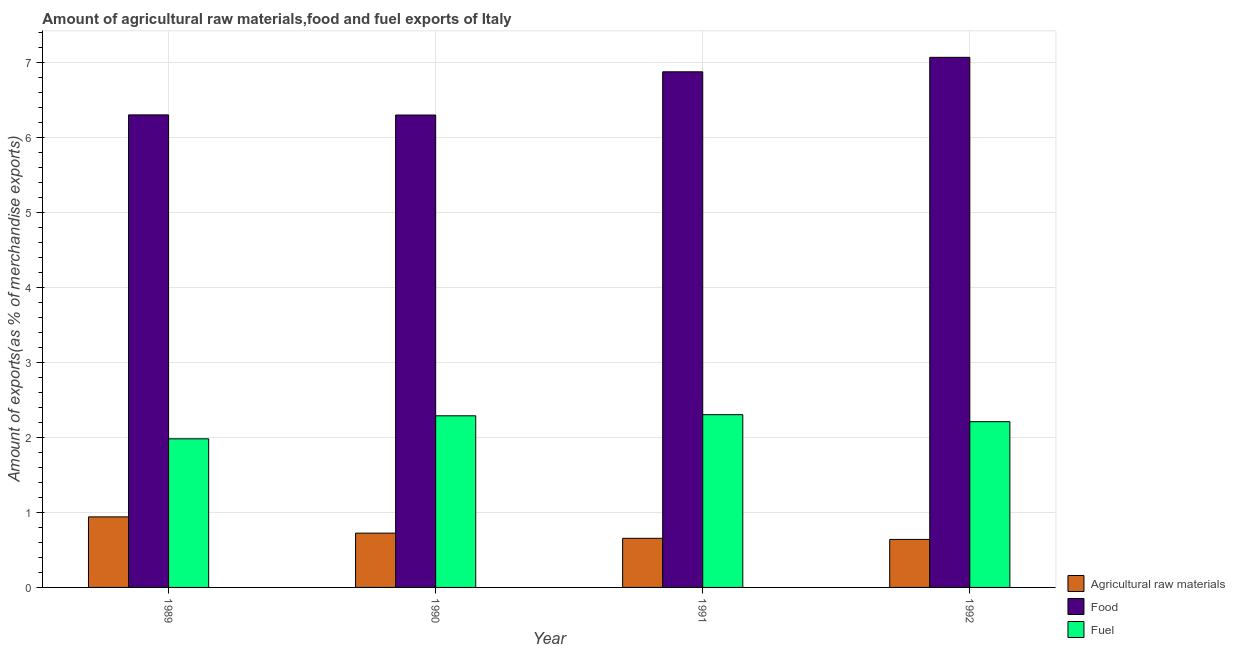How many groups of bars are there?
Offer a very short reply. 4. Are the number of bars per tick equal to the number of legend labels?
Make the answer very short. Yes. Are the number of bars on each tick of the X-axis equal?
Offer a very short reply. Yes. How many bars are there on the 4th tick from the left?
Your answer should be compact. 3. How many bars are there on the 4th tick from the right?
Your response must be concise. 3. In how many cases, is the number of bars for a given year not equal to the number of legend labels?
Keep it short and to the point. 0. What is the percentage of fuel exports in 1990?
Ensure brevity in your answer.  2.29. Across all years, what is the maximum percentage of raw materials exports?
Give a very brief answer. 0.94. Across all years, what is the minimum percentage of raw materials exports?
Give a very brief answer. 0.64. What is the total percentage of raw materials exports in the graph?
Your response must be concise. 2.96. What is the difference between the percentage of raw materials exports in 1991 and that in 1992?
Ensure brevity in your answer.  0.01. What is the difference between the percentage of fuel exports in 1992 and the percentage of food exports in 1990?
Provide a short and direct response. -0.08. What is the average percentage of fuel exports per year?
Your response must be concise. 2.2. In the year 1992, what is the difference between the percentage of food exports and percentage of raw materials exports?
Offer a terse response. 0. What is the ratio of the percentage of food exports in 1991 to that in 1992?
Give a very brief answer. 0.97. Is the difference between the percentage of fuel exports in 1989 and 1992 greater than the difference between the percentage of raw materials exports in 1989 and 1992?
Offer a very short reply. No. What is the difference between the highest and the second highest percentage of raw materials exports?
Give a very brief answer. 0.22. What is the difference between the highest and the lowest percentage of food exports?
Offer a terse response. 0.77. Is the sum of the percentage of raw materials exports in 1991 and 1992 greater than the maximum percentage of food exports across all years?
Your answer should be compact. Yes. What does the 1st bar from the left in 1990 represents?
Provide a succinct answer. Agricultural raw materials. What does the 2nd bar from the right in 1991 represents?
Your answer should be very brief. Food. Is it the case that in every year, the sum of the percentage of raw materials exports and percentage of food exports is greater than the percentage of fuel exports?
Provide a short and direct response. Yes. Are the values on the major ticks of Y-axis written in scientific E-notation?
Your answer should be compact. No. Where does the legend appear in the graph?
Offer a terse response. Bottom right. How many legend labels are there?
Make the answer very short. 3. How are the legend labels stacked?
Offer a terse response. Vertical. What is the title of the graph?
Provide a short and direct response. Amount of agricultural raw materials,food and fuel exports of Italy. Does "Hydroelectric sources" appear as one of the legend labels in the graph?
Provide a succinct answer. No. What is the label or title of the Y-axis?
Provide a short and direct response. Amount of exports(as % of merchandise exports). What is the Amount of exports(as % of merchandise exports) of Agricultural raw materials in 1989?
Offer a terse response. 0.94. What is the Amount of exports(as % of merchandise exports) in Food in 1989?
Ensure brevity in your answer.  6.3. What is the Amount of exports(as % of merchandise exports) in Fuel in 1989?
Keep it short and to the point. 1.98. What is the Amount of exports(as % of merchandise exports) in Agricultural raw materials in 1990?
Give a very brief answer. 0.72. What is the Amount of exports(as % of merchandise exports) of Food in 1990?
Ensure brevity in your answer.  6.3. What is the Amount of exports(as % of merchandise exports) in Fuel in 1990?
Provide a succinct answer. 2.29. What is the Amount of exports(as % of merchandise exports) of Agricultural raw materials in 1991?
Provide a succinct answer. 0.66. What is the Amount of exports(as % of merchandise exports) in Food in 1991?
Your answer should be compact. 6.88. What is the Amount of exports(as % of merchandise exports) of Fuel in 1991?
Provide a succinct answer. 2.3. What is the Amount of exports(as % of merchandise exports) in Agricultural raw materials in 1992?
Provide a succinct answer. 0.64. What is the Amount of exports(as % of merchandise exports) in Food in 1992?
Ensure brevity in your answer.  7.07. What is the Amount of exports(as % of merchandise exports) of Fuel in 1992?
Ensure brevity in your answer.  2.21. Across all years, what is the maximum Amount of exports(as % of merchandise exports) in Agricultural raw materials?
Give a very brief answer. 0.94. Across all years, what is the maximum Amount of exports(as % of merchandise exports) of Food?
Make the answer very short. 7.07. Across all years, what is the maximum Amount of exports(as % of merchandise exports) in Fuel?
Provide a succinct answer. 2.3. Across all years, what is the minimum Amount of exports(as % of merchandise exports) in Agricultural raw materials?
Your answer should be very brief. 0.64. Across all years, what is the minimum Amount of exports(as % of merchandise exports) in Food?
Keep it short and to the point. 6.3. Across all years, what is the minimum Amount of exports(as % of merchandise exports) in Fuel?
Your response must be concise. 1.98. What is the total Amount of exports(as % of merchandise exports) of Agricultural raw materials in the graph?
Your response must be concise. 2.96. What is the total Amount of exports(as % of merchandise exports) in Food in the graph?
Provide a succinct answer. 26.55. What is the total Amount of exports(as % of merchandise exports) of Fuel in the graph?
Make the answer very short. 8.79. What is the difference between the Amount of exports(as % of merchandise exports) of Agricultural raw materials in 1989 and that in 1990?
Offer a terse response. 0.22. What is the difference between the Amount of exports(as % of merchandise exports) of Food in 1989 and that in 1990?
Your answer should be very brief. 0. What is the difference between the Amount of exports(as % of merchandise exports) of Fuel in 1989 and that in 1990?
Your response must be concise. -0.31. What is the difference between the Amount of exports(as % of merchandise exports) of Agricultural raw materials in 1989 and that in 1991?
Your answer should be very brief. 0.29. What is the difference between the Amount of exports(as % of merchandise exports) of Food in 1989 and that in 1991?
Provide a short and direct response. -0.57. What is the difference between the Amount of exports(as % of merchandise exports) in Fuel in 1989 and that in 1991?
Offer a very short reply. -0.32. What is the difference between the Amount of exports(as % of merchandise exports) in Agricultural raw materials in 1989 and that in 1992?
Your answer should be compact. 0.3. What is the difference between the Amount of exports(as % of merchandise exports) of Food in 1989 and that in 1992?
Keep it short and to the point. -0.77. What is the difference between the Amount of exports(as % of merchandise exports) of Fuel in 1989 and that in 1992?
Make the answer very short. -0.23. What is the difference between the Amount of exports(as % of merchandise exports) of Agricultural raw materials in 1990 and that in 1991?
Make the answer very short. 0.07. What is the difference between the Amount of exports(as % of merchandise exports) of Food in 1990 and that in 1991?
Your response must be concise. -0.58. What is the difference between the Amount of exports(as % of merchandise exports) of Fuel in 1990 and that in 1991?
Give a very brief answer. -0.01. What is the difference between the Amount of exports(as % of merchandise exports) of Agricultural raw materials in 1990 and that in 1992?
Your answer should be compact. 0.08. What is the difference between the Amount of exports(as % of merchandise exports) in Food in 1990 and that in 1992?
Ensure brevity in your answer.  -0.77. What is the difference between the Amount of exports(as % of merchandise exports) of Fuel in 1990 and that in 1992?
Your answer should be compact. 0.08. What is the difference between the Amount of exports(as % of merchandise exports) of Agricultural raw materials in 1991 and that in 1992?
Ensure brevity in your answer.  0.01. What is the difference between the Amount of exports(as % of merchandise exports) in Food in 1991 and that in 1992?
Your answer should be very brief. -0.19. What is the difference between the Amount of exports(as % of merchandise exports) in Fuel in 1991 and that in 1992?
Offer a terse response. 0.09. What is the difference between the Amount of exports(as % of merchandise exports) in Agricultural raw materials in 1989 and the Amount of exports(as % of merchandise exports) in Food in 1990?
Your answer should be very brief. -5.36. What is the difference between the Amount of exports(as % of merchandise exports) in Agricultural raw materials in 1989 and the Amount of exports(as % of merchandise exports) in Fuel in 1990?
Make the answer very short. -1.35. What is the difference between the Amount of exports(as % of merchandise exports) in Food in 1989 and the Amount of exports(as % of merchandise exports) in Fuel in 1990?
Offer a terse response. 4.01. What is the difference between the Amount of exports(as % of merchandise exports) of Agricultural raw materials in 1989 and the Amount of exports(as % of merchandise exports) of Food in 1991?
Your response must be concise. -5.94. What is the difference between the Amount of exports(as % of merchandise exports) in Agricultural raw materials in 1989 and the Amount of exports(as % of merchandise exports) in Fuel in 1991?
Provide a succinct answer. -1.36. What is the difference between the Amount of exports(as % of merchandise exports) of Food in 1989 and the Amount of exports(as % of merchandise exports) of Fuel in 1991?
Provide a succinct answer. 4. What is the difference between the Amount of exports(as % of merchandise exports) in Agricultural raw materials in 1989 and the Amount of exports(as % of merchandise exports) in Food in 1992?
Provide a short and direct response. -6.13. What is the difference between the Amount of exports(as % of merchandise exports) in Agricultural raw materials in 1989 and the Amount of exports(as % of merchandise exports) in Fuel in 1992?
Your response must be concise. -1.27. What is the difference between the Amount of exports(as % of merchandise exports) of Food in 1989 and the Amount of exports(as % of merchandise exports) of Fuel in 1992?
Offer a very short reply. 4.09. What is the difference between the Amount of exports(as % of merchandise exports) in Agricultural raw materials in 1990 and the Amount of exports(as % of merchandise exports) in Food in 1991?
Your answer should be very brief. -6.15. What is the difference between the Amount of exports(as % of merchandise exports) of Agricultural raw materials in 1990 and the Amount of exports(as % of merchandise exports) of Fuel in 1991?
Provide a succinct answer. -1.58. What is the difference between the Amount of exports(as % of merchandise exports) of Food in 1990 and the Amount of exports(as % of merchandise exports) of Fuel in 1991?
Offer a terse response. 4. What is the difference between the Amount of exports(as % of merchandise exports) of Agricultural raw materials in 1990 and the Amount of exports(as % of merchandise exports) of Food in 1992?
Offer a very short reply. -6.35. What is the difference between the Amount of exports(as % of merchandise exports) in Agricultural raw materials in 1990 and the Amount of exports(as % of merchandise exports) in Fuel in 1992?
Offer a very short reply. -1.49. What is the difference between the Amount of exports(as % of merchandise exports) of Food in 1990 and the Amount of exports(as % of merchandise exports) of Fuel in 1992?
Keep it short and to the point. 4.09. What is the difference between the Amount of exports(as % of merchandise exports) in Agricultural raw materials in 1991 and the Amount of exports(as % of merchandise exports) in Food in 1992?
Your response must be concise. -6.42. What is the difference between the Amount of exports(as % of merchandise exports) of Agricultural raw materials in 1991 and the Amount of exports(as % of merchandise exports) of Fuel in 1992?
Offer a terse response. -1.56. What is the difference between the Amount of exports(as % of merchandise exports) of Food in 1991 and the Amount of exports(as % of merchandise exports) of Fuel in 1992?
Provide a succinct answer. 4.67. What is the average Amount of exports(as % of merchandise exports) of Agricultural raw materials per year?
Give a very brief answer. 0.74. What is the average Amount of exports(as % of merchandise exports) in Food per year?
Provide a short and direct response. 6.64. What is the average Amount of exports(as % of merchandise exports) in Fuel per year?
Offer a very short reply. 2.2. In the year 1989, what is the difference between the Amount of exports(as % of merchandise exports) of Agricultural raw materials and Amount of exports(as % of merchandise exports) of Food?
Offer a terse response. -5.36. In the year 1989, what is the difference between the Amount of exports(as % of merchandise exports) of Agricultural raw materials and Amount of exports(as % of merchandise exports) of Fuel?
Provide a short and direct response. -1.04. In the year 1989, what is the difference between the Amount of exports(as % of merchandise exports) in Food and Amount of exports(as % of merchandise exports) in Fuel?
Ensure brevity in your answer.  4.32. In the year 1990, what is the difference between the Amount of exports(as % of merchandise exports) of Agricultural raw materials and Amount of exports(as % of merchandise exports) of Food?
Your answer should be compact. -5.58. In the year 1990, what is the difference between the Amount of exports(as % of merchandise exports) of Agricultural raw materials and Amount of exports(as % of merchandise exports) of Fuel?
Keep it short and to the point. -1.57. In the year 1990, what is the difference between the Amount of exports(as % of merchandise exports) of Food and Amount of exports(as % of merchandise exports) of Fuel?
Your response must be concise. 4.01. In the year 1991, what is the difference between the Amount of exports(as % of merchandise exports) in Agricultural raw materials and Amount of exports(as % of merchandise exports) in Food?
Provide a succinct answer. -6.22. In the year 1991, what is the difference between the Amount of exports(as % of merchandise exports) in Agricultural raw materials and Amount of exports(as % of merchandise exports) in Fuel?
Your answer should be very brief. -1.65. In the year 1991, what is the difference between the Amount of exports(as % of merchandise exports) in Food and Amount of exports(as % of merchandise exports) in Fuel?
Your answer should be very brief. 4.57. In the year 1992, what is the difference between the Amount of exports(as % of merchandise exports) of Agricultural raw materials and Amount of exports(as % of merchandise exports) of Food?
Ensure brevity in your answer.  -6.43. In the year 1992, what is the difference between the Amount of exports(as % of merchandise exports) in Agricultural raw materials and Amount of exports(as % of merchandise exports) in Fuel?
Your response must be concise. -1.57. In the year 1992, what is the difference between the Amount of exports(as % of merchandise exports) of Food and Amount of exports(as % of merchandise exports) of Fuel?
Your answer should be compact. 4.86. What is the ratio of the Amount of exports(as % of merchandise exports) in Agricultural raw materials in 1989 to that in 1990?
Ensure brevity in your answer.  1.3. What is the ratio of the Amount of exports(as % of merchandise exports) in Fuel in 1989 to that in 1990?
Your answer should be compact. 0.87. What is the ratio of the Amount of exports(as % of merchandise exports) in Agricultural raw materials in 1989 to that in 1991?
Your response must be concise. 1.44. What is the ratio of the Amount of exports(as % of merchandise exports) of Food in 1989 to that in 1991?
Make the answer very short. 0.92. What is the ratio of the Amount of exports(as % of merchandise exports) of Fuel in 1989 to that in 1991?
Provide a succinct answer. 0.86. What is the ratio of the Amount of exports(as % of merchandise exports) in Agricultural raw materials in 1989 to that in 1992?
Give a very brief answer. 1.47. What is the ratio of the Amount of exports(as % of merchandise exports) in Food in 1989 to that in 1992?
Provide a short and direct response. 0.89. What is the ratio of the Amount of exports(as % of merchandise exports) of Fuel in 1989 to that in 1992?
Ensure brevity in your answer.  0.9. What is the ratio of the Amount of exports(as % of merchandise exports) in Agricultural raw materials in 1990 to that in 1991?
Your answer should be compact. 1.11. What is the ratio of the Amount of exports(as % of merchandise exports) of Food in 1990 to that in 1991?
Ensure brevity in your answer.  0.92. What is the ratio of the Amount of exports(as % of merchandise exports) of Agricultural raw materials in 1990 to that in 1992?
Offer a terse response. 1.13. What is the ratio of the Amount of exports(as % of merchandise exports) in Food in 1990 to that in 1992?
Offer a very short reply. 0.89. What is the ratio of the Amount of exports(as % of merchandise exports) in Fuel in 1990 to that in 1992?
Your response must be concise. 1.04. What is the ratio of the Amount of exports(as % of merchandise exports) in Agricultural raw materials in 1991 to that in 1992?
Your answer should be very brief. 1.02. What is the ratio of the Amount of exports(as % of merchandise exports) of Food in 1991 to that in 1992?
Provide a succinct answer. 0.97. What is the ratio of the Amount of exports(as % of merchandise exports) of Fuel in 1991 to that in 1992?
Give a very brief answer. 1.04. What is the difference between the highest and the second highest Amount of exports(as % of merchandise exports) of Agricultural raw materials?
Give a very brief answer. 0.22. What is the difference between the highest and the second highest Amount of exports(as % of merchandise exports) of Food?
Your response must be concise. 0.19. What is the difference between the highest and the second highest Amount of exports(as % of merchandise exports) of Fuel?
Provide a succinct answer. 0.01. What is the difference between the highest and the lowest Amount of exports(as % of merchandise exports) in Agricultural raw materials?
Your response must be concise. 0.3. What is the difference between the highest and the lowest Amount of exports(as % of merchandise exports) in Food?
Make the answer very short. 0.77. What is the difference between the highest and the lowest Amount of exports(as % of merchandise exports) in Fuel?
Make the answer very short. 0.32. 